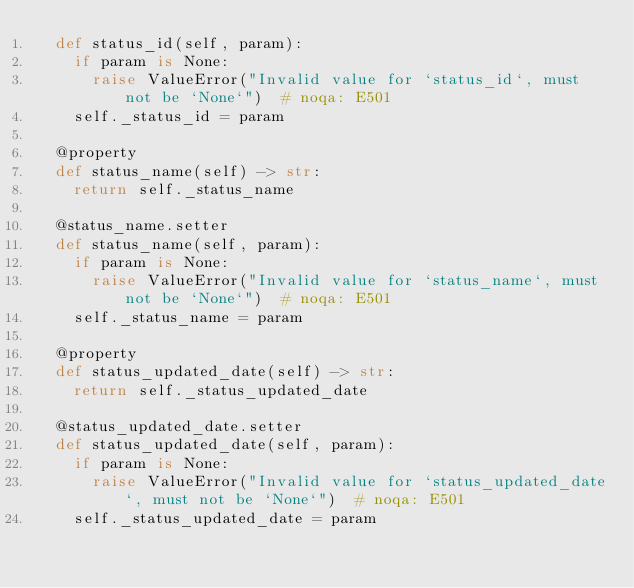Convert code to text. <code><loc_0><loc_0><loc_500><loc_500><_Python_>	def status_id(self, param):
		if param is None:
			raise ValueError("Invalid value for `status_id`, must not be `None`")  # noqa: E501
		self._status_id = param

	@property
	def status_name(self) -> str:
		return self._status_name

	@status_name.setter
	def status_name(self, param):
		if param is None:
			raise ValueError("Invalid value for `status_name`, must not be `None`")  # noqa: E501
		self._status_name = param

	@property
	def status_updated_date(self) -> str:
		return self._status_updated_date

	@status_updated_date.setter
	def status_updated_date(self, param):
		if param is None:
			raise ValueError("Invalid value for `status_updated_date`, must not be `None`")  # noqa: E501
		self._status_updated_date = param

</code> 